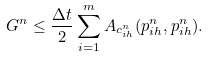Convert formula to latex. <formula><loc_0><loc_0><loc_500><loc_500>G ^ { n } \leq \frac { \Delta t } { 2 } \sum _ { i = 1 } ^ { m } A _ { c _ { i h } ^ { n } } ( p _ { i h } ^ { n } , p _ { i h } ^ { n } ) .</formula> 